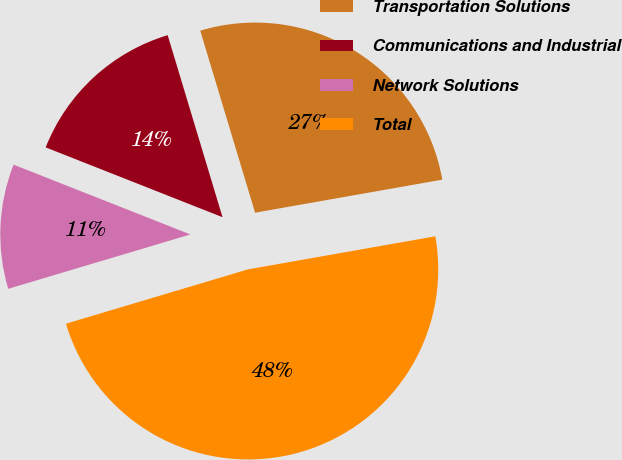<chart> <loc_0><loc_0><loc_500><loc_500><pie_chart><fcel>Transportation Solutions<fcel>Communications and Industrial<fcel>Network Solutions<fcel>Total<nl><fcel>26.88%<fcel>14.36%<fcel>10.6%<fcel>48.17%<nl></chart> 